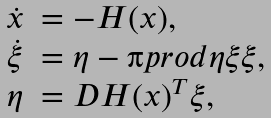Convert formula to latex. <formula><loc_0><loc_0><loc_500><loc_500>\begin{array} { c l } \dot { x } & = - H ( x ) , \\ \dot { \xi } & = \eta - \i p r o d { \eta } { \xi } \xi , \\ \eta & = D H ( x ) ^ { T } \xi , \end{array}</formula> 